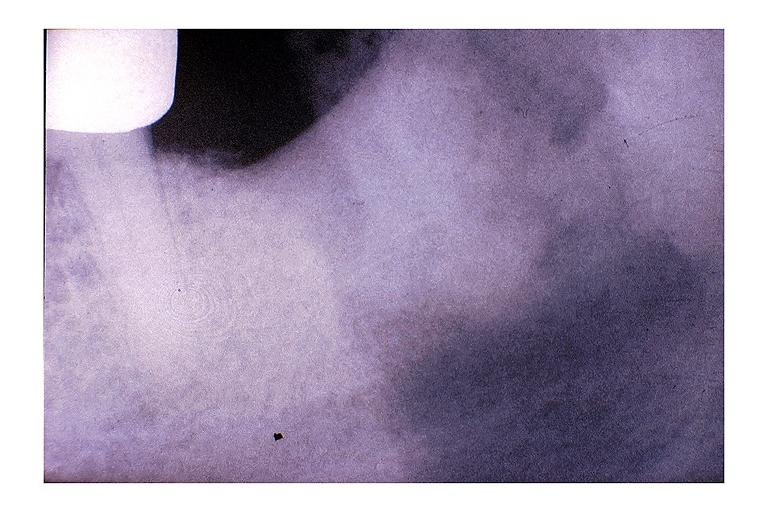does this image show chronic osteomyelitis?
Answer the question using a single word or phrase. Yes 